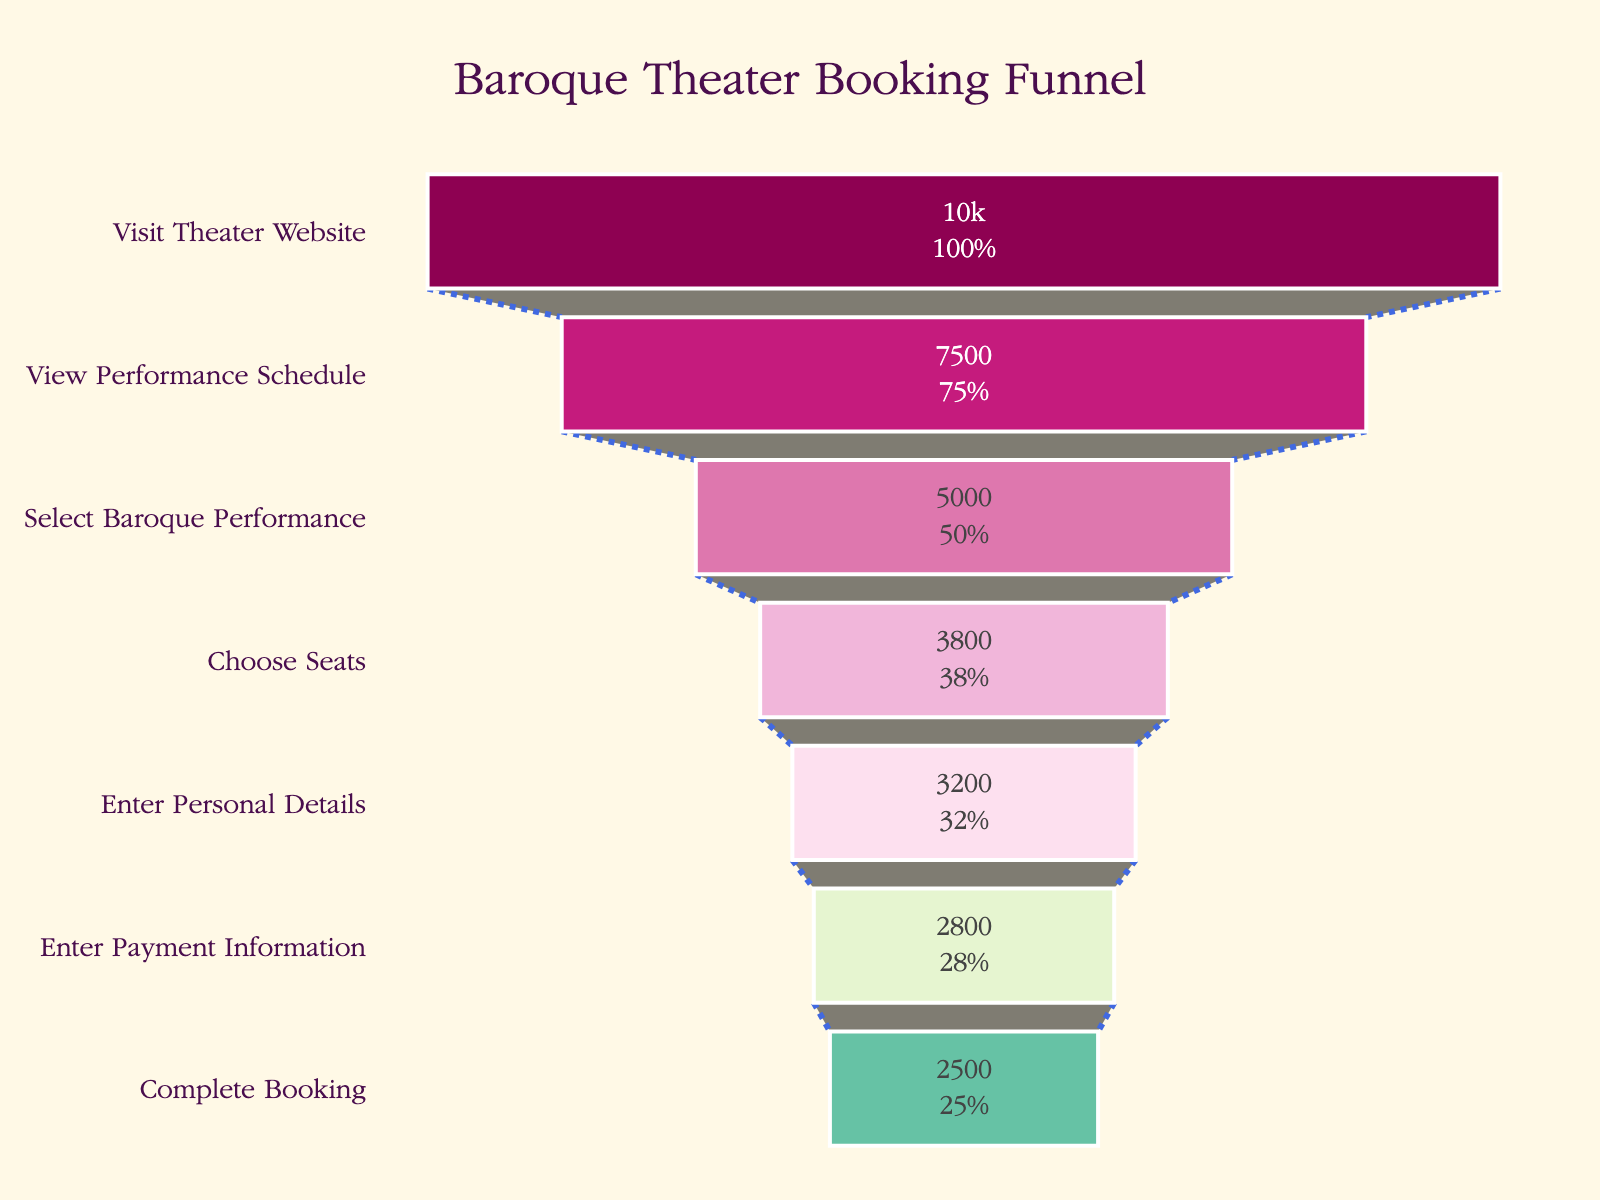What is the title of the funnel chart? The title of the funnel chart is typically located at the top center of the figure. It is clearly labeled and visually distinct.
Answer: Baroque Theater Booking Funnel How many stages are there in the theater booking funnel? The funnel chart shows different horizontal layers, each representing a stage in the funnel. Counting these layers will give the total number of stages.
Answer: 7 Which stage has the highest number of visitors? The stage at the top of the funnel chart has the highest number because the funnel is widest at the top. This stage is visibly labeled, and the numerical value is given.
Answer: Visit Theater Website What is the percentage of visitors who complete the booking compared to those who visit the theater website? The funnel chart displays both the counts and percentages. Look for the percentage displayed at the last stage relative to the first stage.
Answer: 25% How many visitors drop off between viewing the performance schedule and selecting a Baroque performance? Subtract the count at the "Select Baroque Performance" stage from the count at the "View Performance Schedule" stage.
Answer: 2500 Which stage has the lowest number of visitors? The stage at the bottom of the funnel chart has the lowest number because it is the narrowest part of the funnel. This stage is visibly labeled, and the numerical value is given.
Answer: Complete Booking What is the total number of visitors who drop off after entering payment information but before completing the booking? Subtract the count at the "Complete Booking" stage from the count at the "Enter Payment Information" stage.
Answer: 300 How many visitors enter personal details? Identify the "Enter Personal Details" stage in the funnel chart and note the numerical value provided alongside.
Answer: 3200 How does the number of visitors choosing seats compare to the number selecting a Baroque performance? Compare the count at the "Choose Seats" stage to the count at the "Select Baroque Performance" stage.
Answer: 1200 less What is the difference in the number of visitors between choosing seats and entering personal details? Subtract the count at the "Choice Seats" stage from the count at the "Enter Personal Details" stage.
Answer: 600 